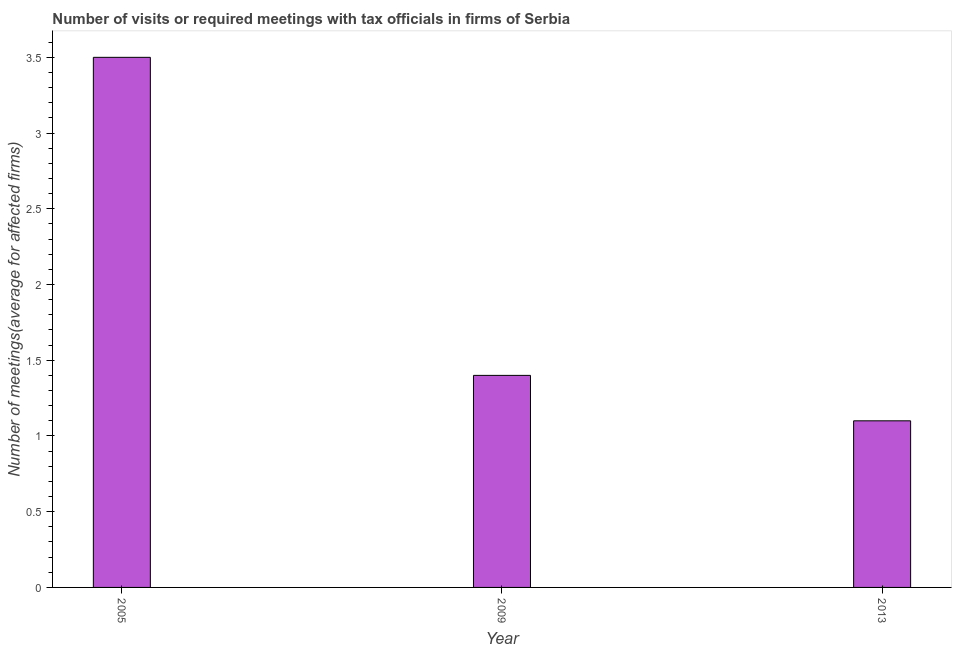Does the graph contain grids?
Your answer should be very brief. No. What is the title of the graph?
Make the answer very short. Number of visits or required meetings with tax officials in firms of Serbia. What is the label or title of the Y-axis?
Keep it short and to the point. Number of meetings(average for affected firms). Across all years, what is the minimum number of required meetings with tax officials?
Your response must be concise. 1.1. In which year was the number of required meetings with tax officials maximum?
Provide a succinct answer. 2005. In which year was the number of required meetings with tax officials minimum?
Provide a succinct answer. 2013. What is the sum of the number of required meetings with tax officials?
Ensure brevity in your answer.  6. In how many years, is the number of required meetings with tax officials greater than 3.3 ?
Keep it short and to the point. 1. Do a majority of the years between 2009 and 2005 (inclusive) have number of required meetings with tax officials greater than 3.4 ?
Offer a terse response. No. What is the ratio of the number of required meetings with tax officials in 2005 to that in 2009?
Offer a terse response. 2.5. What is the difference between the highest and the second highest number of required meetings with tax officials?
Ensure brevity in your answer.  2.1. What is the difference between the highest and the lowest number of required meetings with tax officials?
Provide a succinct answer. 2.4. How many bars are there?
Provide a short and direct response. 3. How many years are there in the graph?
Make the answer very short. 3. What is the difference between two consecutive major ticks on the Y-axis?
Your response must be concise. 0.5. What is the difference between the Number of meetings(average for affected firms) in 2005 and 2009?
Ensure brevity in your answer.  2.1. What is the difference between the Number of meetings(average for affected firms) in 2009 and 2013?
Offer a terse response. 0.3. What is the ratio of the Number of meetings(average for affected firms) in 2005 to that in 2009?
Provide a succinct answer. 2.5. What is the ratio of the Number of meetings(average for affected firms) in 2005 to that in 2013?
Your answer should be very brief. 3.18. What is the ratio of the Number of meetings(average for affected firms) in 2009 to that in 2013?
Your answer should be very brief. 1.27. 